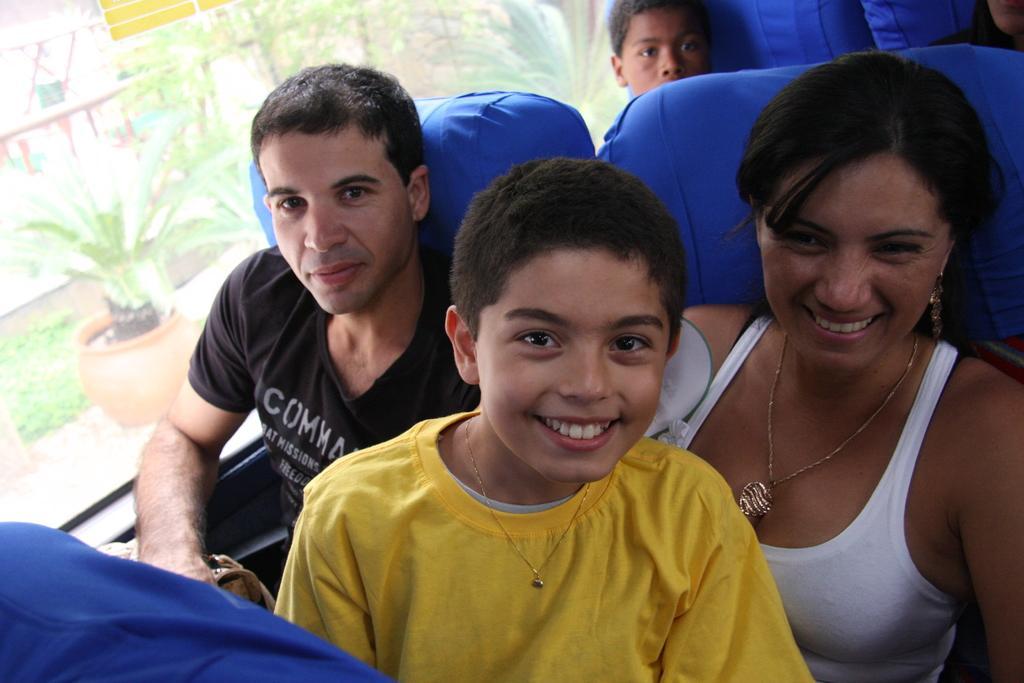Could you give a brief overview of what you see in this image? In the center of the image we can see a person sitting in the bus. In the background we can see plants and fencing. 